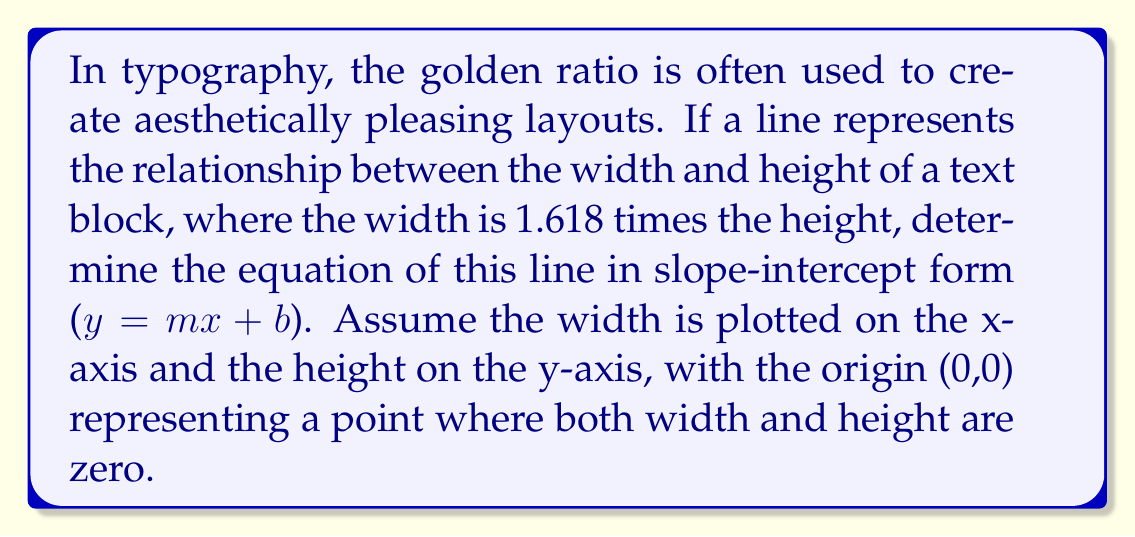Help me with this question. Let's approach this step-by-step:

1) The golden ratio states that the width is 1.618 times the height. This gives us our first relationship:
   $$ \text{width} = 1.618 \times \text{height} $$

2) In our coordinate system, width is x and height is y:
   $$ x = 1.618y $$

3) To get this into slope-intercept form (y = mx + b), we need to solve for y:
   $$ y = \frac{1}{1.618}x $$

4) Simplify the fraction:
   $$ y \approx 0.618x $$

5) There's no y-intercept (b) in this equation because the line passes through the origin (0,0).

6) Therefore, our final equation in slope-intercept form is:
   $$ y = 0.618x $$

This line has a slope of approximately 0.618, which is the reciprocal of the golden ratio. It passes through the origin and represents all points where the width (x) is 1.618 times the height (y), embodying the golden ratio in a linear format.
Answer: $y = 0.618x$ 